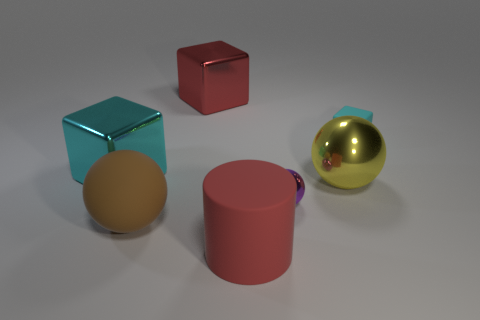There is a sphere that is the same material as the yellow object; what is its color?
Make the answer very short. Purple. Is there anything else that is the same size as the cylinder?
Offer a terse response. Yes. There is a matte thing on the left side of the red rubber thing; is its color the same as the big cube to the left of the big rubber ball?
Offer a very short reply. No. Are there more tiny balls that are behind the red metal cube than purple objects on the left side of the red cylinder?
Provide a succinct answer. No. There is another shiny object that is the same shape as the tiny metal object; what is its color?
Ensure brevity in your answer.  Yellow. Is there any other thing that is the same shape as the small cyan matte object?
Keep it short and to the point. Yes. There is a tiny cyan rubber object; does it have the same shape as the cyan object that is on the left side of the rubber cylinder?
Provide a short and direct response. Yes. How many other things are the same material as the small purple sphere?
Offer a very short reply. 3. There is a rubber cylinder; is its color the same as the shiny block right of the brown rubber ball?
Offer a very short reply. Yes. What is the red thing that is behind the big yellow thing made of?
Provide a succinct answer. Metal. 